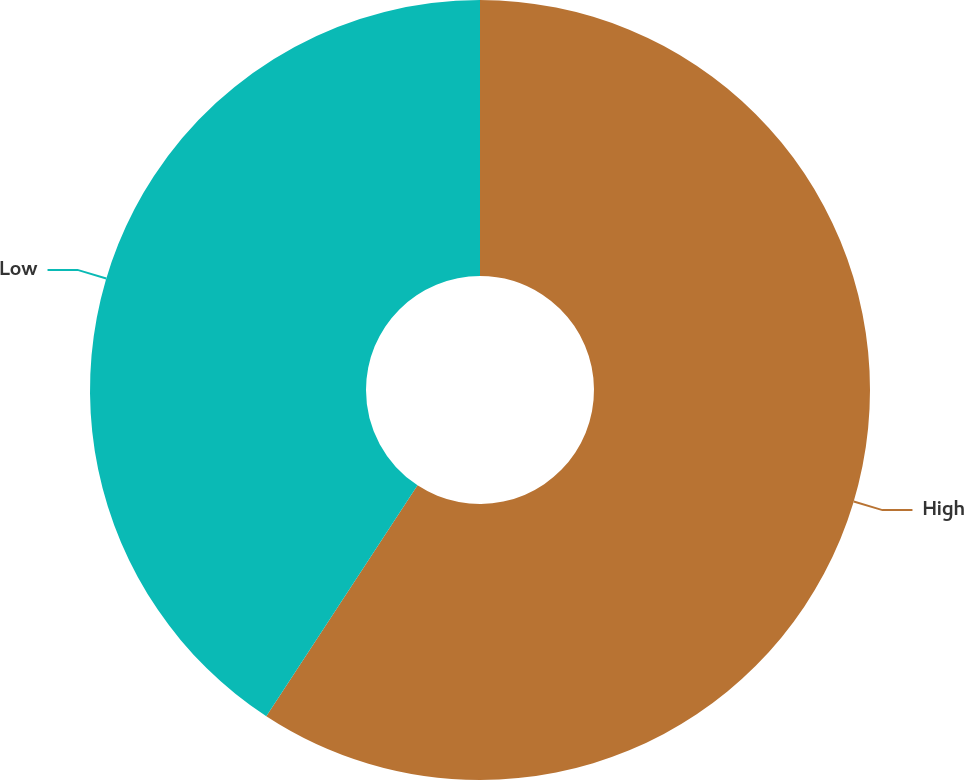Convert chart. <chart><loc_0><loc_0><loc_500><loc_500><pie_chart><fcel>High<fcel>Low<nl><fcel>59.23%<fcel>40.77%<nl></chart> 